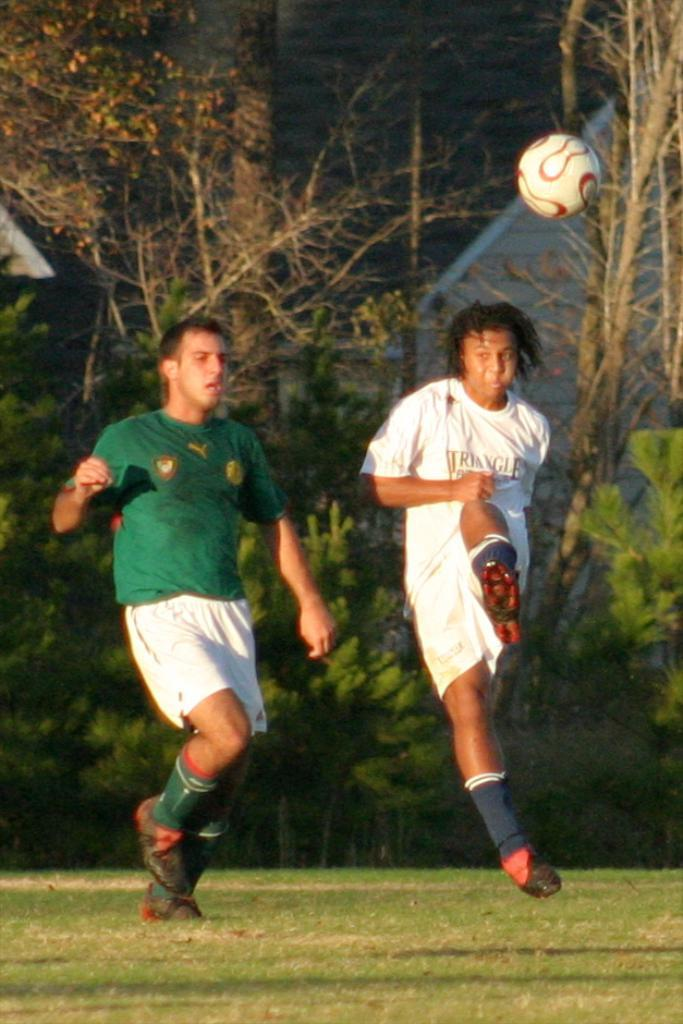What type of vegetation is present in the image? There are trees in the image. What is covering the ground in the image? There is grass on the ground in the image. What type of structures can be seen in the image? There are houses in the image. What type of liquid is being poured from the toad in the image? There is no toad present in the image, and therefore no liquid can be poured from it. What emotion is being expressed by the houses in the image? Houses do not express emotions, so this question cannot be answered definitively based on the provided facts. 